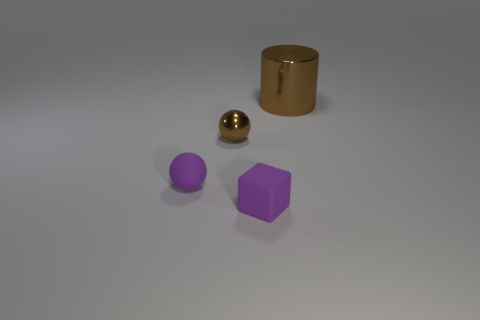Subtract all cubes. How many objects are left? 3 Subtract all green cubes. How many blue cylinders are left? 0 Subtract all things. Subtract all rubber cylinders. How many objects are left? 0 Add 4 large brown things. How many large brown things are left? 5 Add 4 cylinders. How many cylinders exist? 5 Add 3 big gray rubber things. How many objects exist? 7 Subtract 0 green spheres. How many objects are left? 4 Subtract 1 cylinders. How many cylinders are left? 0 Subtract all cyan spheres. Subtract all red cylinders. How many spheres are left? 2 